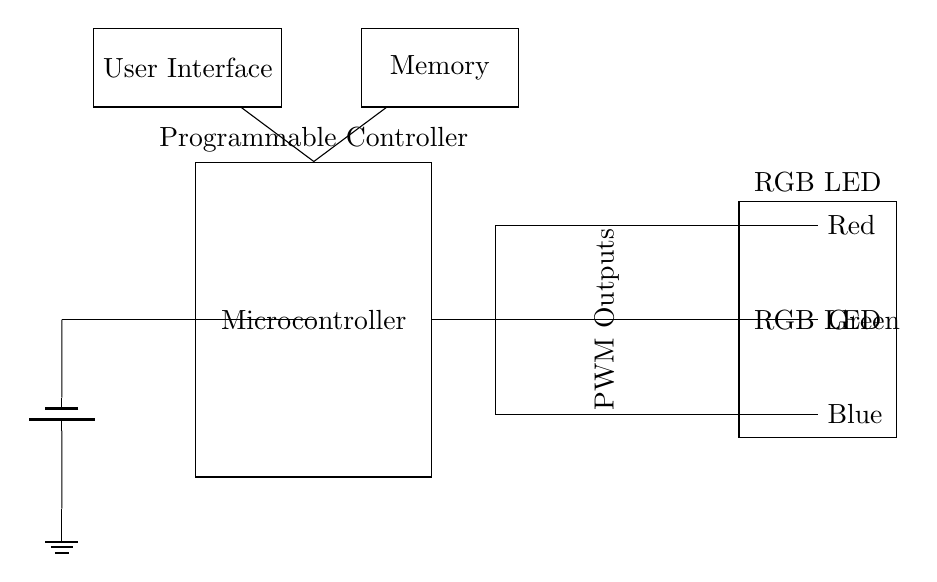What is the main component of this circuit? The main component is the microcontroller, which is responsible for processing input and controlling the RGB LED outputs.
Answer: Microcontroller How many colors can the RGB LED output? The RGB LED can output three primary colors, which are red, green, and blue, each controlled separately.
Answer: Three What is the purpose of the user interface? The user interface allows users to input customized color schemes, which are then processed by the microcontroller to control the RGB LED.
Answer: Input customization What type of modulation is likely used for controlling the LED brightness? The circuit uses Pulse Width Modulation, which is a common technique for managing the brightness of LEDs by varying the duty cycle of the signal.
Answer: Pulse Width Modulation How is power supplied to the microcontroller? Power is supplied to the microcontroller from a battery, as represented by the battery symbol connected directly into the circuit.
Answer: Battery What is the relationship between the microcontroller and memory in this circuit? The microcontroller accesses memory to store data related to the custom color schemes that the user can select, indicating a connection for data retrieval or storage.
Answer: Data storage What type of output does the microcontroller provide to control the RGB LED? The microcontroller provides PWM outputs to control the intensity of the red, green, and blue channels of the RGB LED.
Answer: PWM outputs 